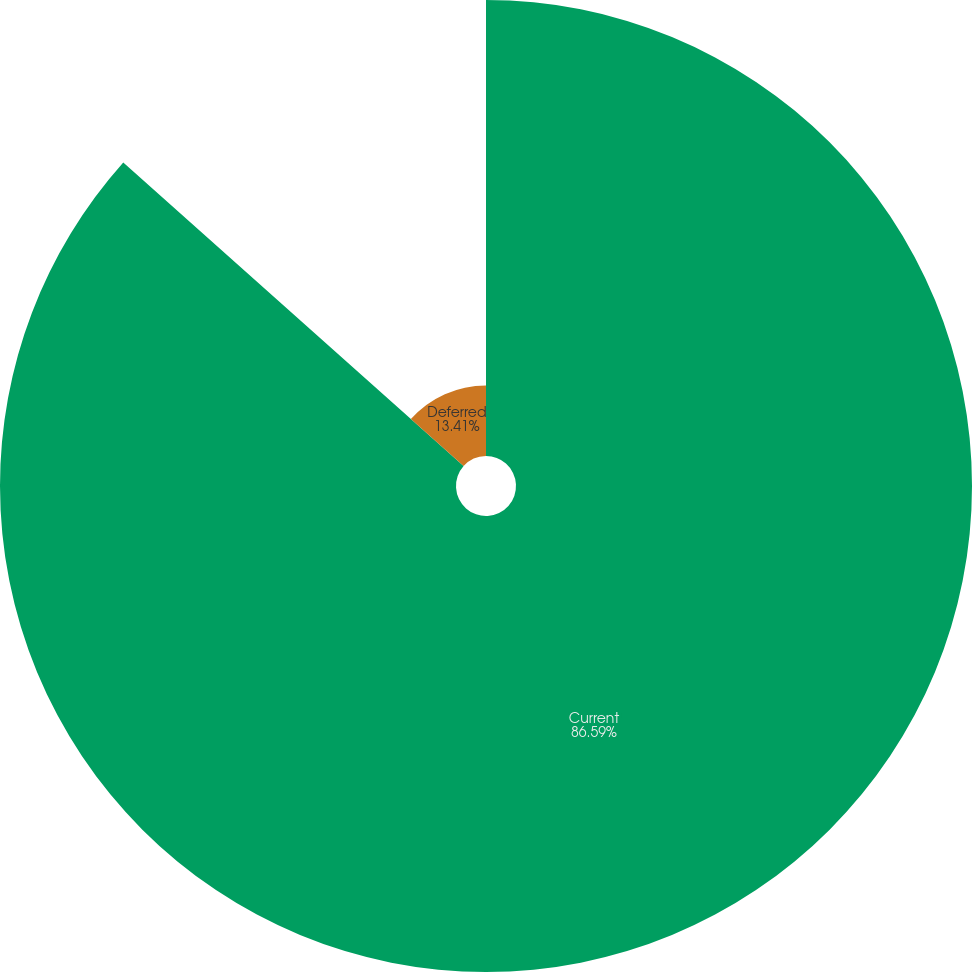Convert chart. <chart><loc_0><loc_0><loc_500><loc_500><pie_chart><fcel>Current<fcel>Deferred<nl><fcel>86.59%<fcel>13.41%<nl></chart> 